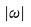Convert formula to latex. <formula><loc_0><loc_0><loc_500><loc_500>| \omega |</formula> 